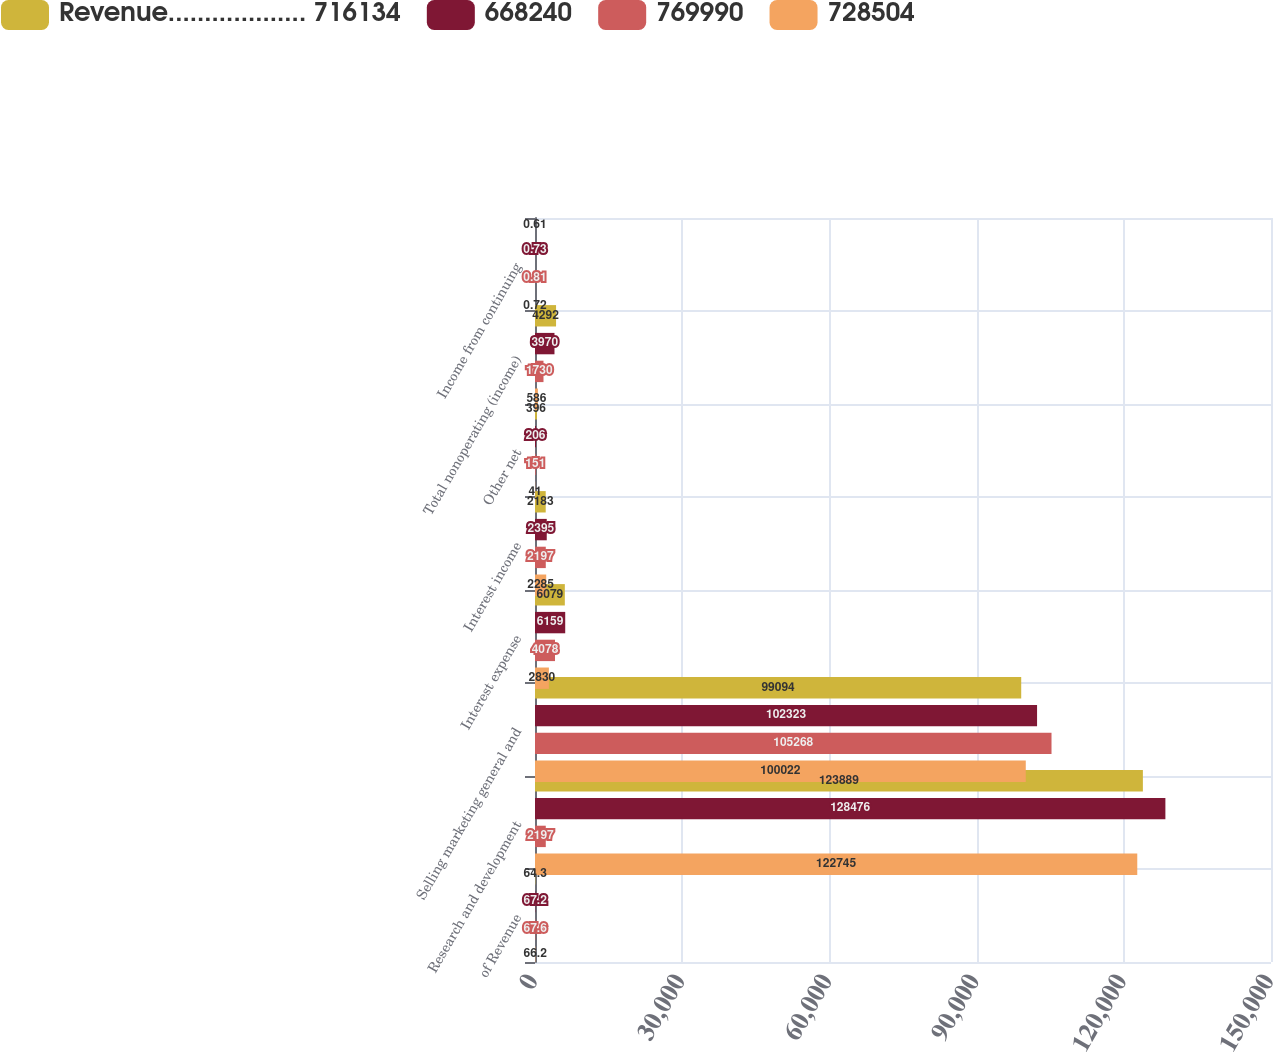Convert chart. <chart><loc_0><loc_0><loc_500><loc_500><stacked_bar_chart><ecel><fcel>of Revenue<fcel>Research and development<fcel>Selling marketing general and<fcel>Interest expense<fcel>Interest income<fcel>Other net<fcel>Total nonoperating (income)<fcel>Income from continuing<nl><fcel>Revenue................... 716134<fcel>64.3<fcel>123889<fcel>99094<fcel>6079<fcel>2183<fcel>396<fcel>4292<fcel>0.61<nl><fcel>668240<fcel>67.2<fcel>128476<fcel>102323<fcel>6159<fcel>2395<fcel>206<fcel>3970<fcel>0.73<nl><fcel>769990<fcel>67.6<fcel>2197<fcel>105268<fcel>4078<fcel>2197<fcel>151<fcel>1730<fcel>0.81<nl><fcel>728504<fcel>66.2<fcel>122745<fcel>100022<fcel>2830<fcel>2285<fcel>41<fcel>586<fcel>0.72<nl></chart> 